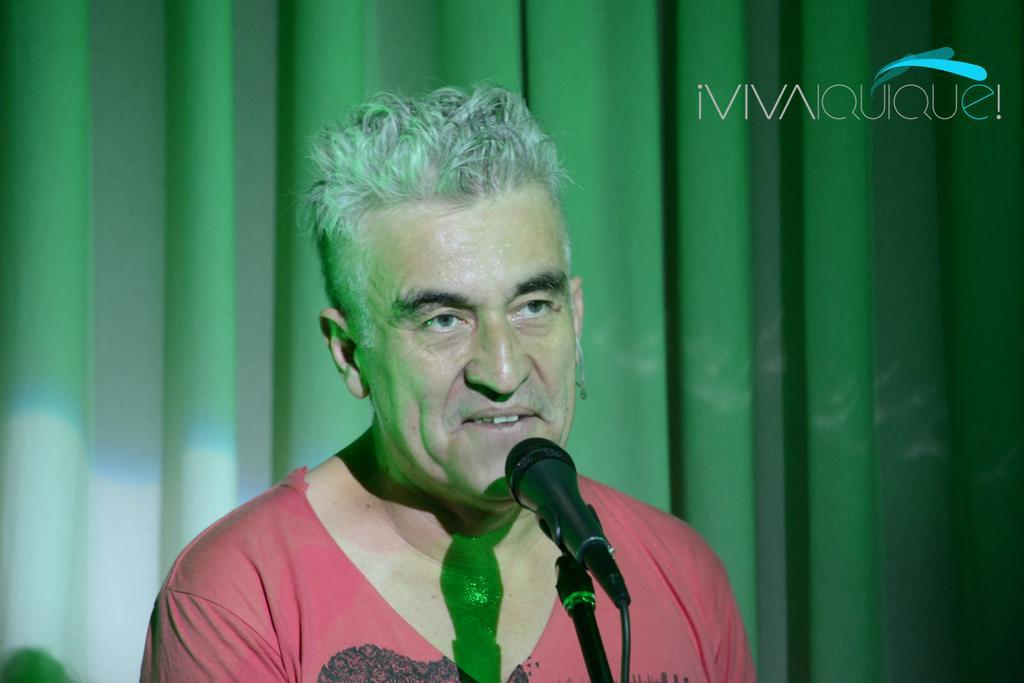Please provide a concise description of this image. In this image, we can see a person. In-front of him, there is a microphone with rod and wire. In the background, we can see curtains. On the right side top of the image, there is a watermark. 